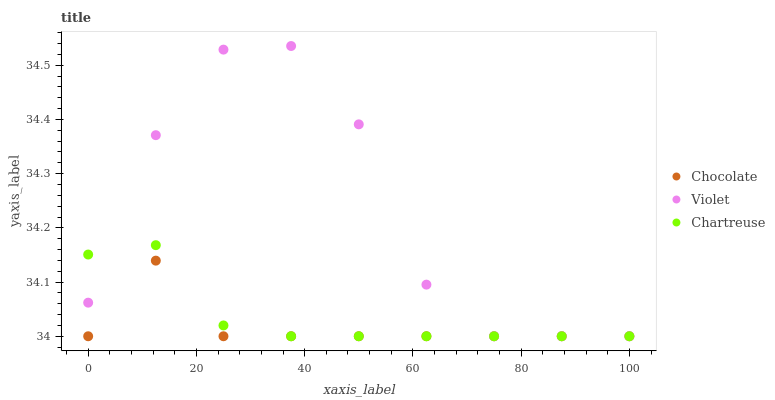Does Chocolate have the minimum area under the curve?
Answer yes or no. Yes. Does Violet have the maximum area under the curve?
Answer yes or no. Yes. Does Violet have the minimum area under the curve?
Answer yes or no. No. Does Chocolate have the maximum area under the curve?
Answer yes or no. No. Is Chartreuse the smoothest?
Answer yes or no. Yes. Is Violet the roughest?
Answer yes or no. Yes. Is Chocolate the smoothest?
Answer yes or no. No. Is Chocolate the roughest?
Answer yes or no. No. Does Chartreuse have the lowest value?
Answer yes or no. Yes. Does Violet have the highest value?
Answer yes or no. Yes. Does Chocolate have the highest value?
Answer yes or no. No. Does Violet intersect Chocolate?
Answer yes or no. Yes. Is Violet less than Chocolate?
Answer yes or no. No. Is Violet greater than Chocolate?
Answer yes or no. No. 